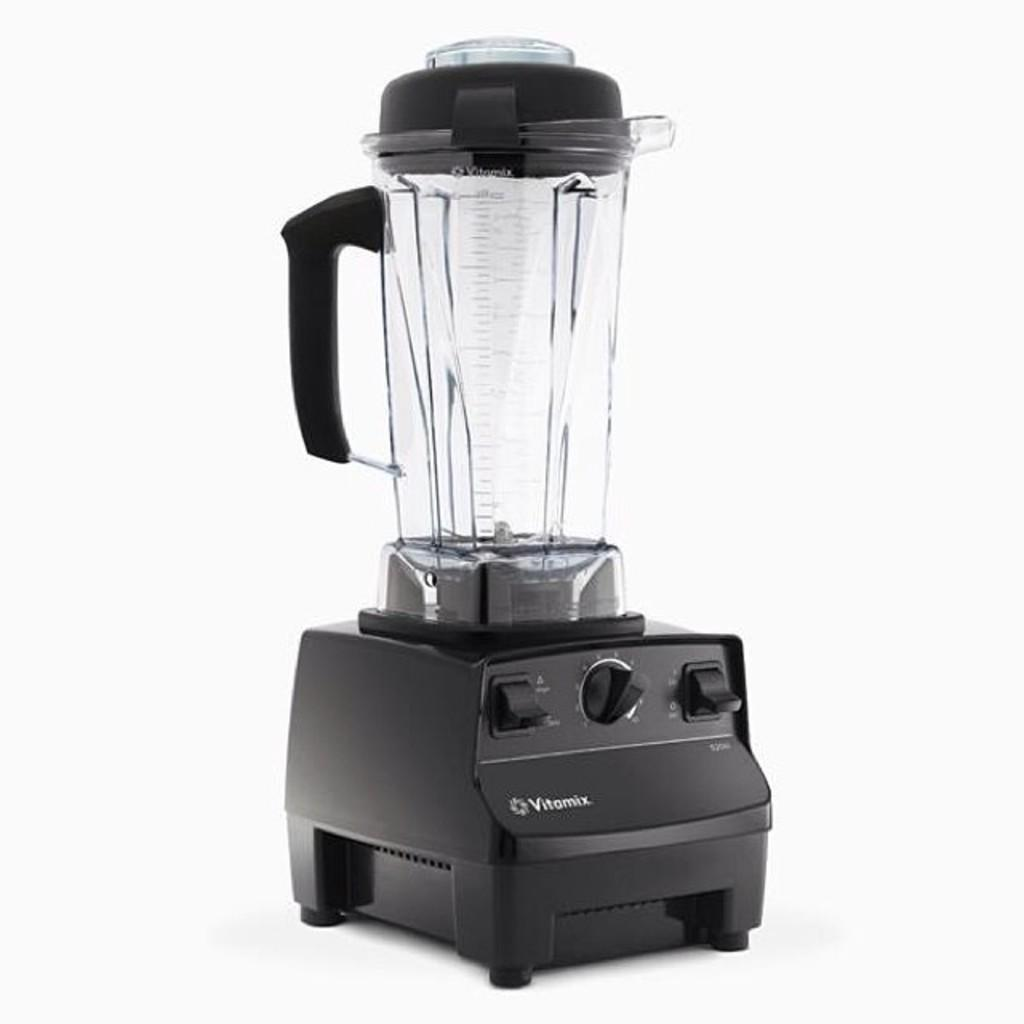<image>
Present a compact description of the photo's key features. A Vitamix blender has a black base, lid and handle. 